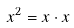<formula> <loc_0><loc_0><loc_500><loc_500>x ^ { 2 } = x \cdot x</formula> 